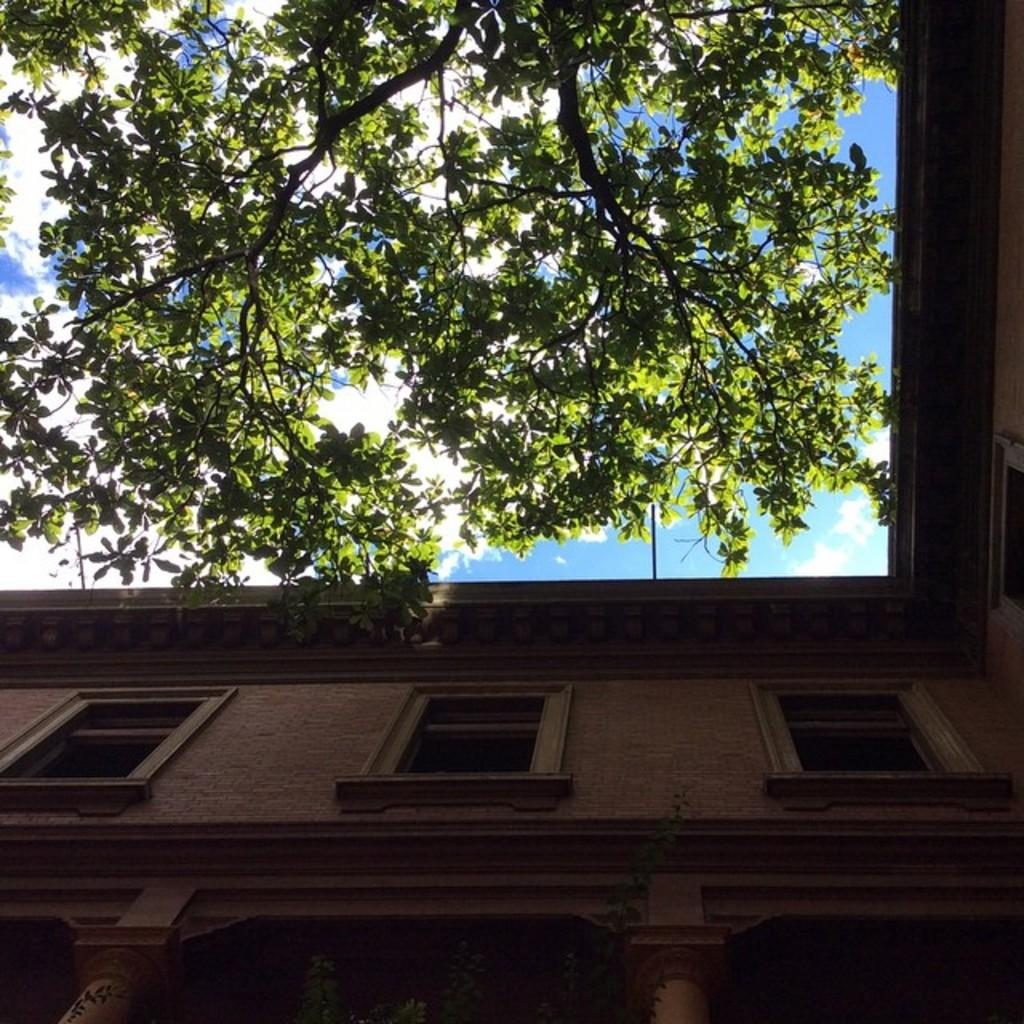What type of structure is present in the image? There is a building in the image. What other natural elements can be seen in the image? There are trees in the image. What is visible in the background of the image? The sky is visible in the background of the image. How would you describe the weather based on the appearance of the sky? The sky appears to be clear, suggesting good weather. Where is the daughter's shelf located in the image? There is no daughter or shelf present in the image. 